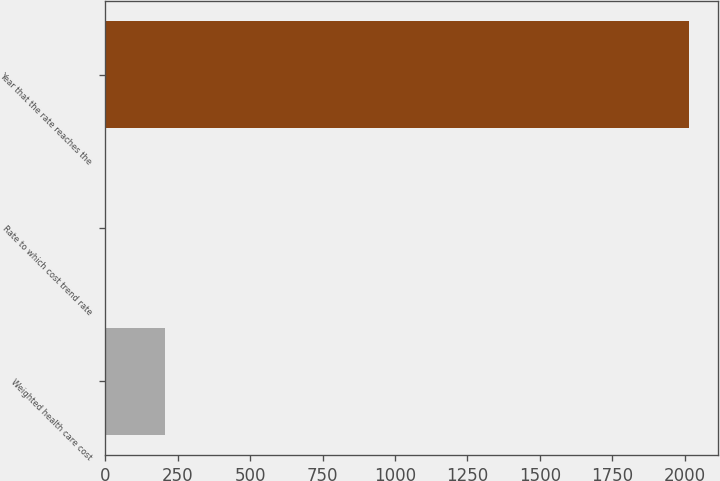Convert chart. <chart><loc_0><loc_0><loc_500><loc_500><bar_chart><fcel>Weighted health care cost<fcel>Rate to which cost trend rate<fcel>Year that the rate reaches the<nl><fcel>205.17<fcel>4.3<fcel>2013<nl></chart> 